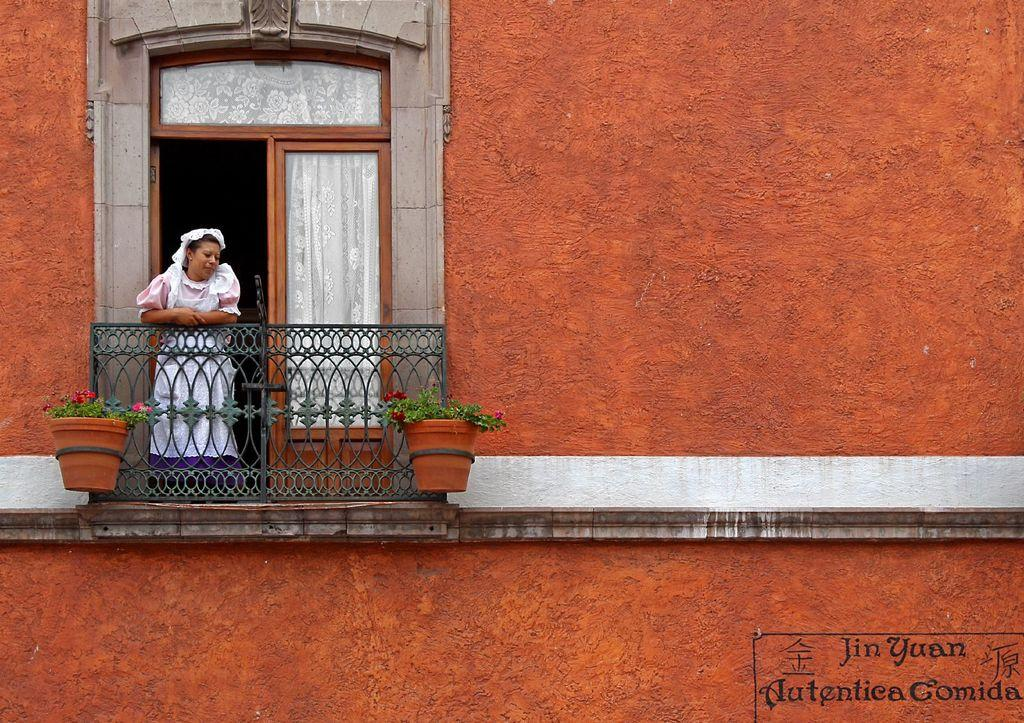What type of structure is visible in the image? There is a building in the image. What can be seen near the edge of the building? There is a railing in the image. Who is standing near the railing? A woman is standing behind the railing. What is located in front of the railing? There are flowers in pots in front of the railing. Where is the entrance to the building? There is a door in the image. What is the tax rate for the flowers in the image? There is no information about tax rates in the image, as it focuses on the building, railing, woman, flowers, and door. 